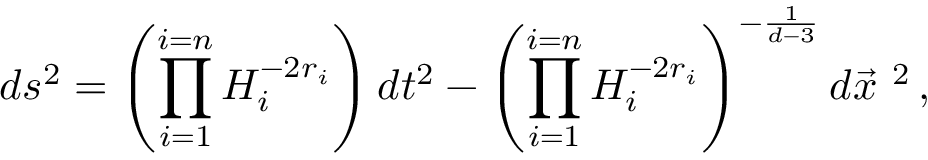<formula> <loc_0><loc_0><loc_500><loc_500>d s ^ { 2 } = \left ( \prod _ { i = 1 } ^ { i = n } H _ { i } ^ { - 2 r _ { i } } \right ) d t ^ { 2 } - \left ( \prod _ { i = 1 } ^ { i = n } H _ { i } ^ { - 2 r _ { i } } \right ) ^ { - \frac { 1 } { d - 3 } } d \vec { x } ^ { \ 2 } \, ,</formula> 